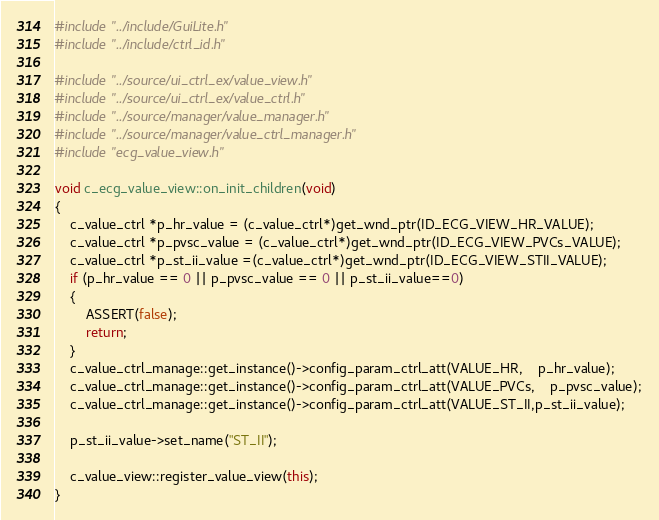<code> <loc_0><loc_0><loc_500><loc_500><_C++_>#include "../include/GuiLite.h"
#include "../include/ctrl_id.h"

#include "../source/ui_ctrl_ex/value_view.h"
#include "../source/ui_ctrl_ex/value_ctrl.h"
#include "../source/manager/value_manager.h"
#include "../source/manager/value_ctrl_manager.h"
#include "ecg_value_view.h"

void c_ecg_value_view::on_init_children(void)
{
	c_value_ctrl *p_hr_value = (c_value_ctrl*)get_wnd_ptr(ID_ECG_VIEW_HR_VALUE);
	c_value_ctrl *p_pvsc_value = (c_value_ctrl*)get_wnd_ptr(ID_ECG_VIEW_PVCs_VALUE);
	c_value_ctrl *p_st_ii_value =(c_value_ctrl*)get_wnd_ptr(ID_ECG_VIEW_STII_VALUE);
	if (p_hr_value == 0 || p_pvsc_value == 0 || p_st_ii_value==0)
	{
		ASSERT(false);
		return;
	}
	c_value_ctrl_manage::get_instance()->config_param_ctrl_att(VALUE_HR,	p_hr_value);
	c_value_ctrl_manage::get_instance()->config_param_ctrl_att(VALUE_PVCs,	p_pvsc_value);
	c_value_ctrl_manage::get_instance()->config_param_ctrl_att(VALUE_ST_II,p_st_ii_value);

	p_st_ii_value->set_name("ST_II");

    c_value_view::register_value_view(this);
}
</code> 